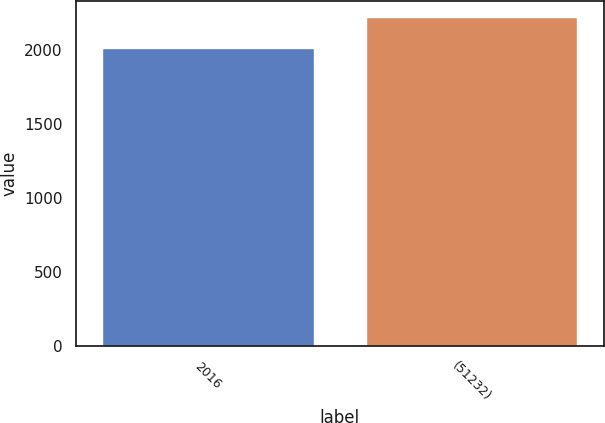Convert chart to OTSL. <chart><loc_0><loc_0><loc_500><loc_500><bar_chart><fcel>2016<fcel>(51232)<nl><fcel>2014<fcel>2218<nl></chart> 